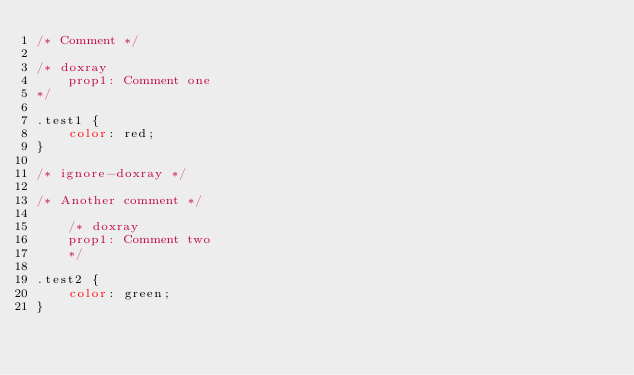Convert code to text. <code><loc_0><loc_0><loc_500><loc_500><_CSS_>/* Comment */

/* doxray
    prop1: Comment one
*/

.test1 {
    color: red;
}

/* ignore-doxray */

/* Another comment */

    /* doxray
    prop1: Comment two
    */

.test2 {
    color: green;
}
</code> 